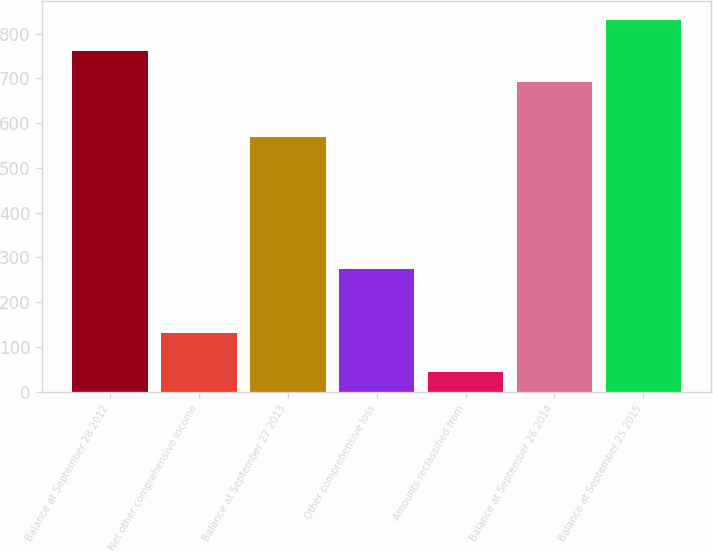Convert chart to OTSL. <chart><loc_0><loc_0><loc_500><loc_500><bar_chart><fcel>Balance at September 28 2012<fcel>Net other comprehensive income<fcel>Balance at September 27 2013<fcel>Other comprehensive loss<fcel>Amounts reclassified from<fcel>Balance at September 26 2014<fcel>Balance at September 25 2015<nl><fcel>761.4<fcel>131<fcel>569<fcel>273.4<fcel>44<fcel>692<fcel>830.8<nl></chart> 